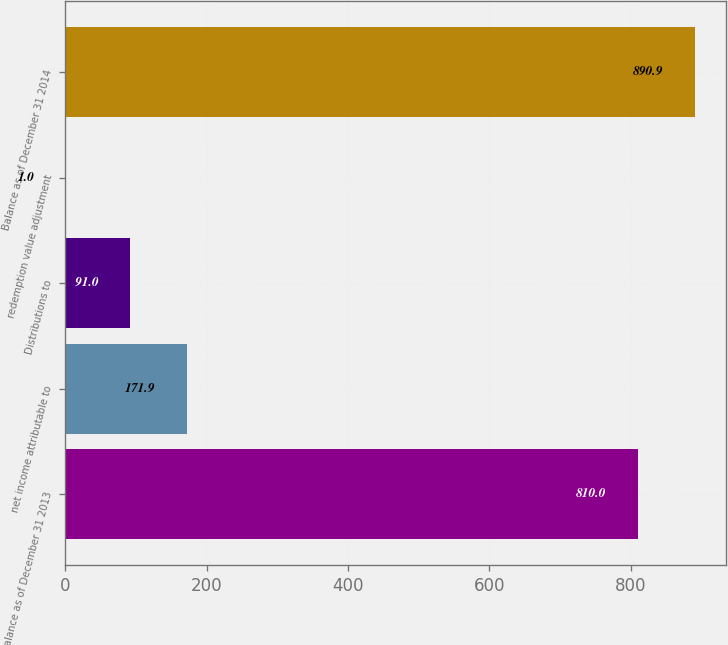Convert chart. <chart><loc_0><loc_0><loc_500><loc_500><bar_chart><fcel>Balance as of December 31 2013<fcel>net income attributable to<fcel>Distributions to<fcel>redemption value adjustment<fcel>Balance as of December 31 2014<nl><fcel>810<fcel>171.9<fcel>91<fcel>1<fcel>890.9<nl></chart> 